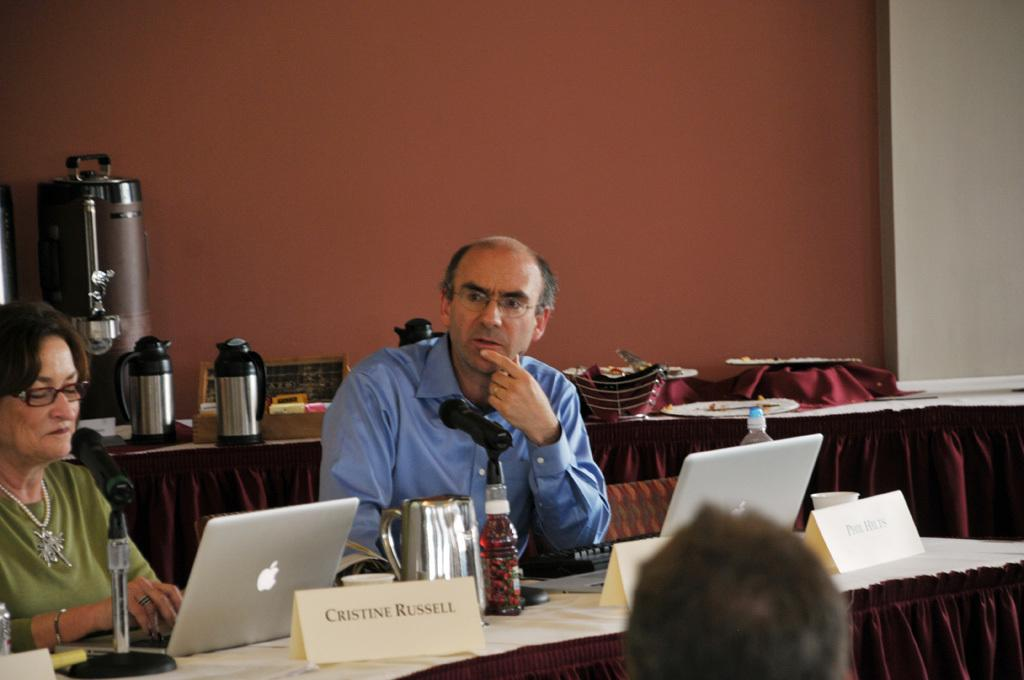How many people are sitting in the image? There are two persons sitting in the image. What equipment is visible in the image? There are microphones with stands and laptops in the image. What items can be seen on the table in the image? There are jars and name boards on the table in the image. What can be seen in the background of the image? There is a wall and a kettle visible in the background of the image. What type of vacation is the person on the left planning based on the items in the image? There is no information in the image to suggest that the persons are planning a vacation. How does the friction between the microphone and the stand affect the sound quality in the image? There is no indication of any friction between the microphone and the stand in the image, and therefore no impact on sound quality can be determined. 